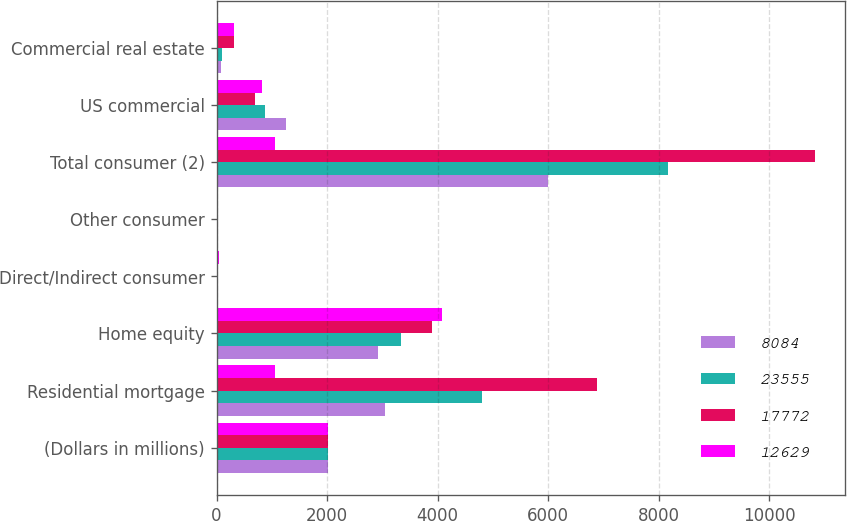Convert chart. <chart><loc_0><loc_0><loc_500><loc_500><stacked_bar_chart><ecel><fcel>(Dollars in millions)<fcel>Residential mortgage<fcel>Home equity<fcel>Direct/Indirect consumer<fcel>Other consumer<fcel>Total consumer (2)<fcel>US commercial<fcel>Commercial real estate<nl><fcel>8084<fcel>2016<fcel>3056<fcel>2918<fcel>28<fcel>2<fcel>6004<fcel>1256<fcel>72<nl><fcel>23555<fcel>2015<fcel>4803<fcel>3337<fcel>24<fcel>1<fcel>8165<fcel>867<fcel>93<nl><fcel>17772<fcel>2014<fcel>6889<fcel>3901<fcel>28<fcel>1<fcel>10819<fcel>701<fcel>321<nl><fcel>12629<fcel>2013<fcel>1061.5<fcel>4075<fcel>35<fcel>18<fcel>1061.5<fcel>819<fcel>322<nl></chart> 